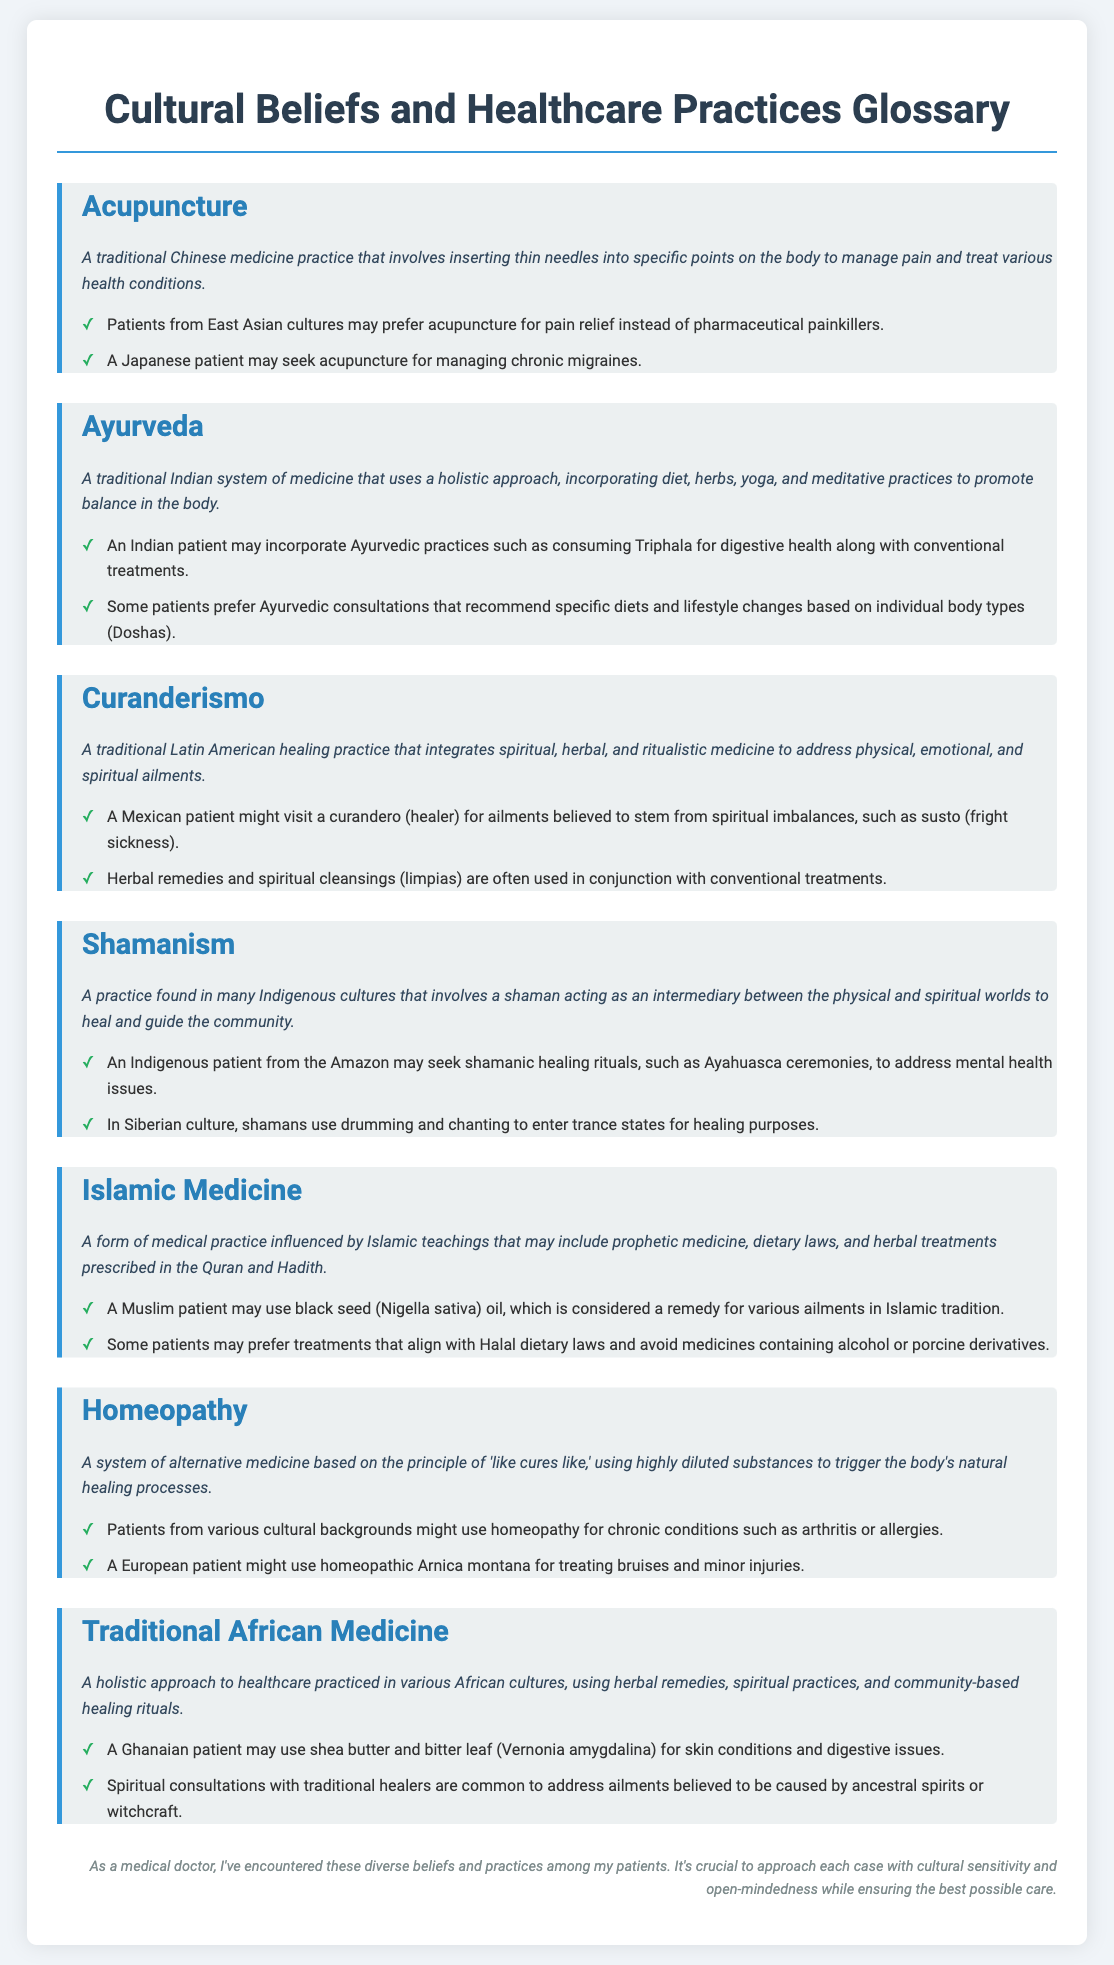What is acupuncture? Acupuncture is defined as a traditional Chinese medicine practice that involves inserting thin needles into specific points on the body to manage pain and treat various health conditions.
Answer: A traditional Chinese medicine practice What does Ayurveda incorporate? Ayurveda is described as a traditional Indian system of medicine that uses a holistic approach, incorporating diet, herbs, yoga, and meditative practices to promote balance in the body.
Answer: Diet, herbs, yoga, and meditative practices What is curanderismo? Curanderismo is defined as a traditional Latin American healing practice that integrates spiritual, herbal, and ritualistic medicine to address physical, emotional, and spiritual ailments.
Answer: A traditional Latin American healing practice What herbal remedy is mentioned in Islamic Medicine? The document mentions black seed (Nigella sativa) oil as a remedy considered in Islamic tradition.
Answer: Black seed (Nigella sativa) oil What type of patients might prefer homeopathy? The glossary indicates that patients from various cultural backgrounds might use homeopathy for chronic conditions such as arthritis or allergies.
Answer: Patients from various cultural backgrounds What is the focus of traditional African medicine? Traditional African medicine is described as a holistic approach to healthcare practiced in various African cultures, using herbal remedies, spiritual practices, and community-based healing rituals.
Answer: A holistic approach to healthcare How many examples are provided for shamanism? The document provides two examples of shamanism under its definition.
Answer: Two examples What practice involves a curandero? The document notes that a Mexican patient might visit a curandero for ailments believed to stem from spiritual imbalances.
Answer: A visit to a curandero What is the main theme of the document? The main theme of the document is to provide definitions and examples of cultural beliefs and healthcare practices.
Answer: Cultural beliefs and healthcare practices 